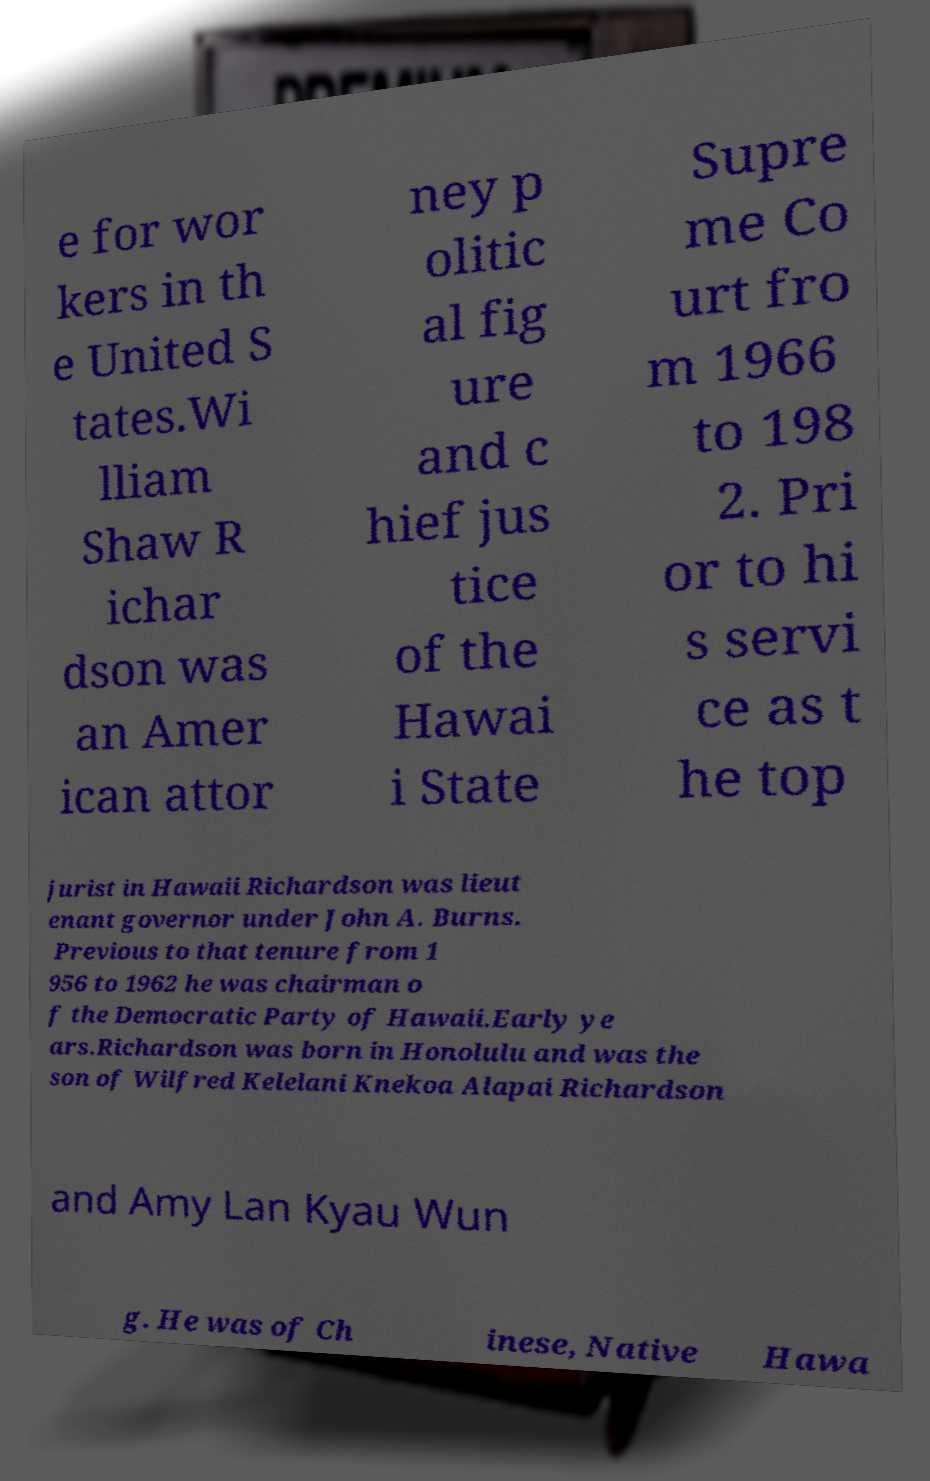What messages or text are displayed in this image? I need them in a readable, typed format. e for wor kers in th e United S tates.Wi lliam Shaw R ichar dson was an Amer ican attor ney p olitic al fig ure and c hief jus tice of the Hawai i State Supre me Co urt fro m 1966 to 198 2. Pri or to hi s servi ce as t he top jurist in Hawaii Richardson was lieut enant governor under John A. Burns. Previous to that tenure from 1 956 to 1962 he was chairman o f the Democratic Party of Hawaii.Early ye ars.Richardson was born in Honolulu and was the son of Wilfred Kelelani Knekoa Alapai Richardson and Amy Lan Kyau Wun g. He was of Ch inese, Native Hawa 